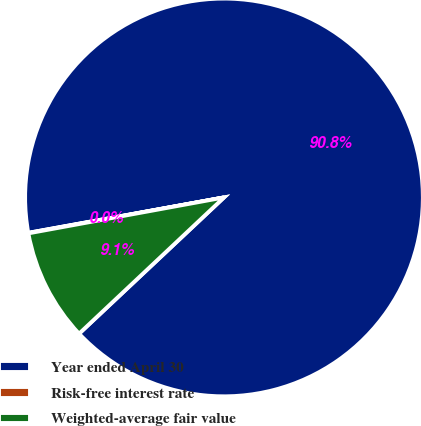<chart> <loc_0><loc_0><loc_500><loc_500><pie_chart><fcel>Year ended April 30<fcel>Risk-free interest rate<fcel>Weighted-average fair value<nl><fcel>90.84%<fcel>0.04%<fcel>9.12%<nl></chart> 